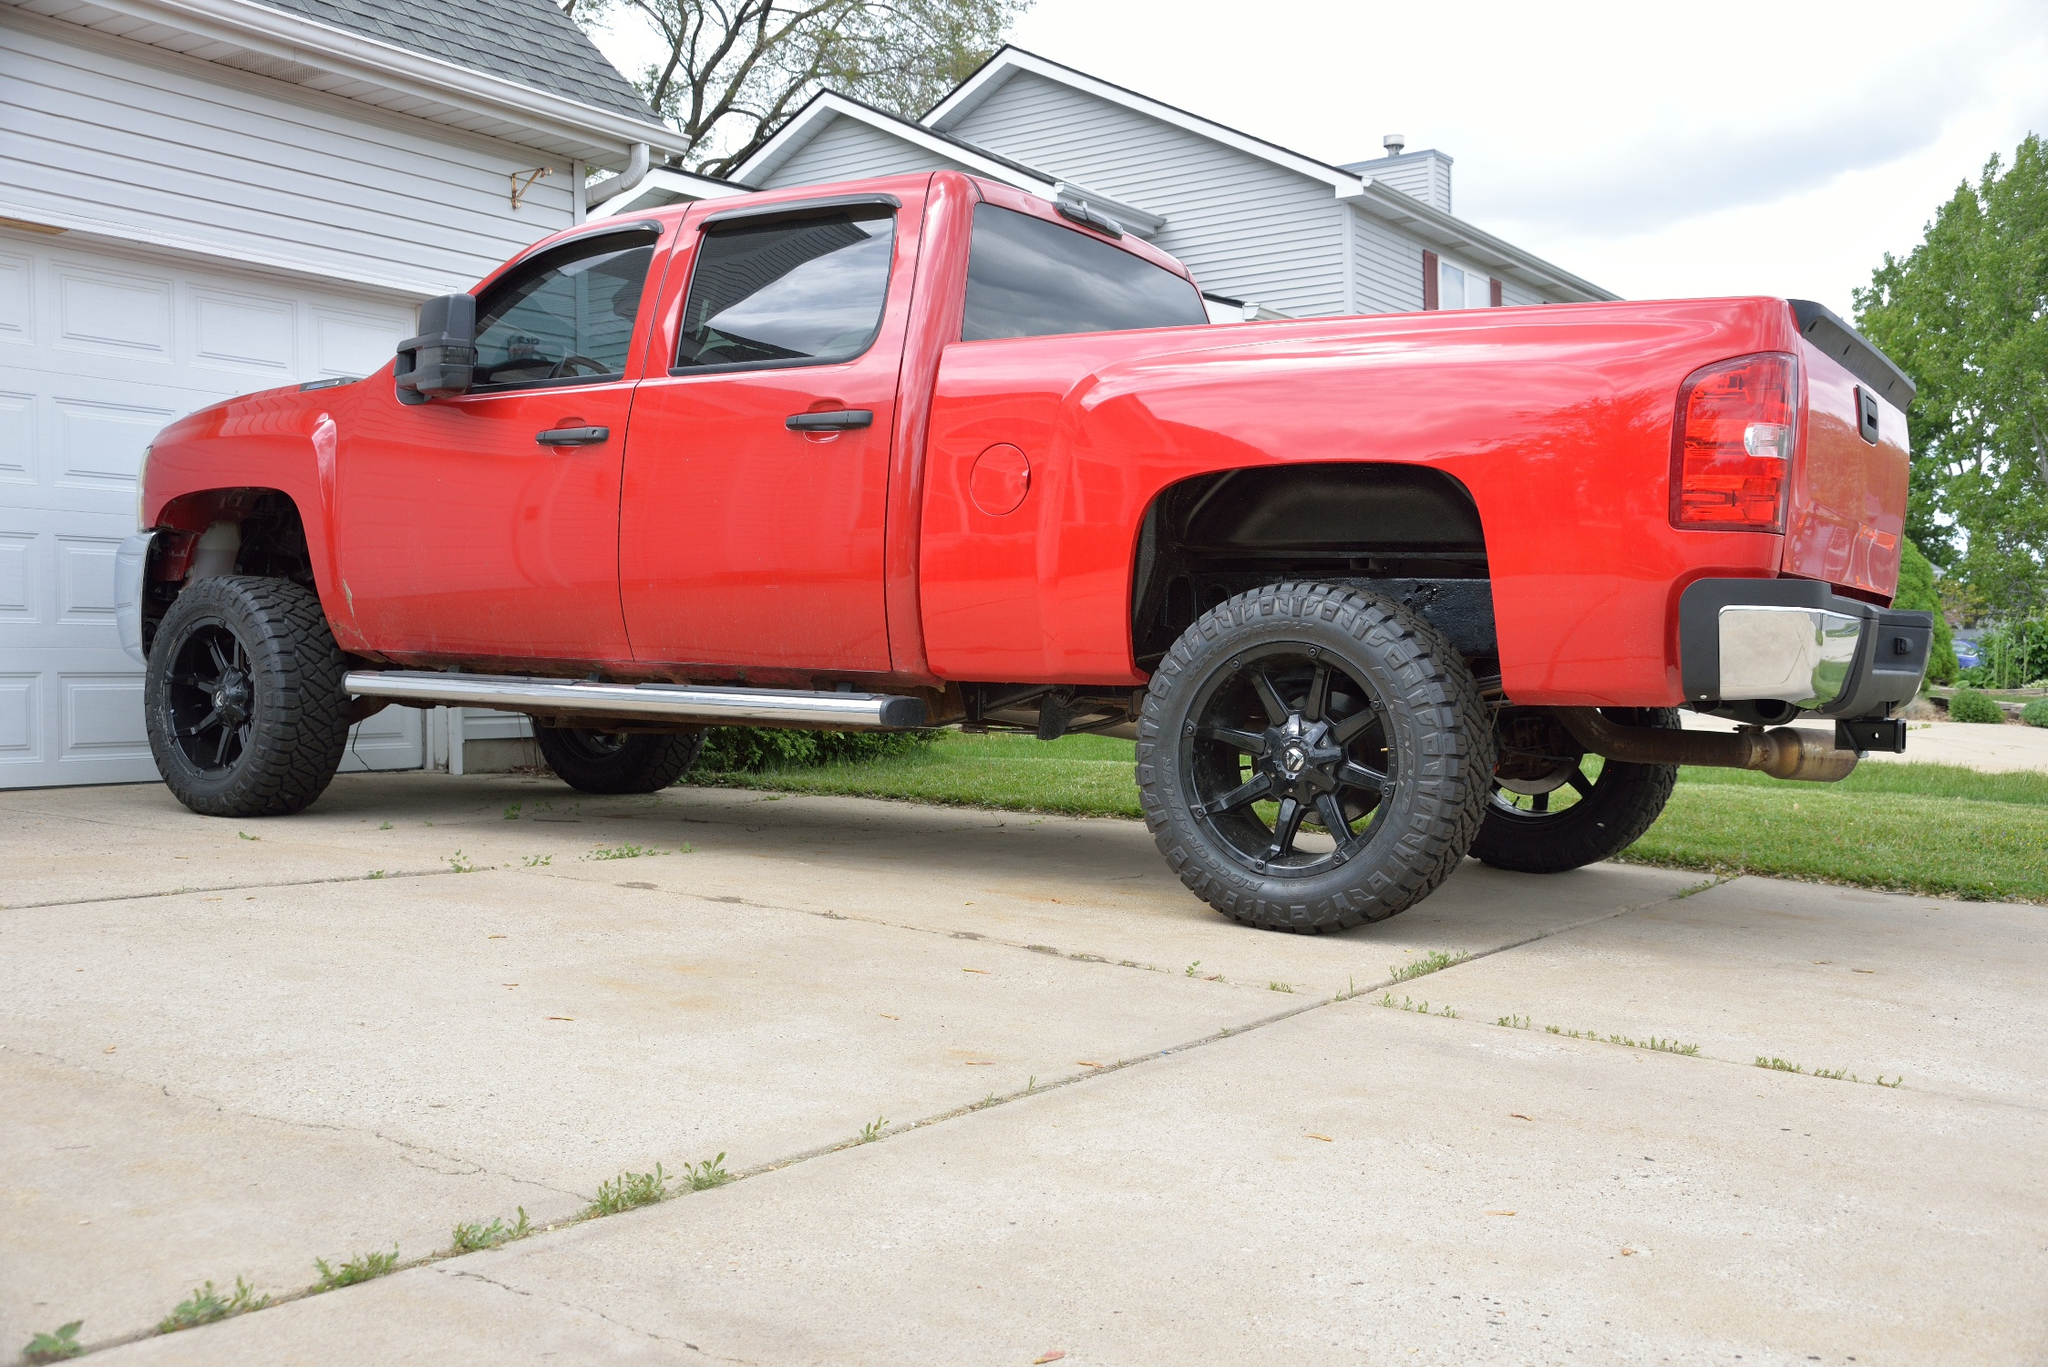Can you describe the main features of this image for me?
 The image captures a scene of suburban tranquility. Dominating the frame is a robust red pickup truck, its body lifted high above black rims and tires. The truck is parked on a concrete driveway, its position parallel to a white garage door that belongs to a gray house. The house and the truck share the space with a verdant lawn, which stretches out to the left of the photo. Above, the sky is a canvas of blue, lightly brushed with wispy clouds. The image does not contain any discernible text. The relative positions of the objects are such that the truck is in the foreground with the house, garage, and lawn extending behind it. The blue sky with its smattering of clouds forms the backdrop of the scene. The image exudes a sense of stillness, with no objects in motion. The number of each type of object is singular: one truck, one house, one garage door, one driveway, and one lawn. The colors present are red (truck), black (rims and tires), white (garage door), gray (house), green (lawn), and blue (sky). 